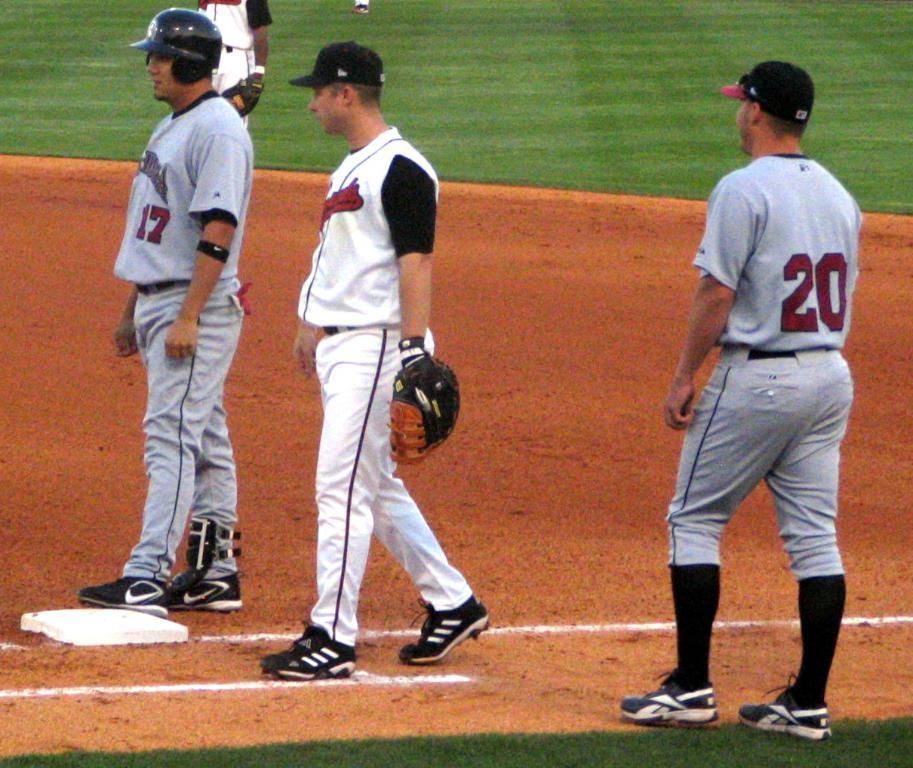<image>
Write a terse but informative summary of the picture. a person wearing 20 on their baseball jersey 